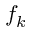<formula> <loc_0><loc_0><loc_500><loc_500>f _ { k }</formula> 